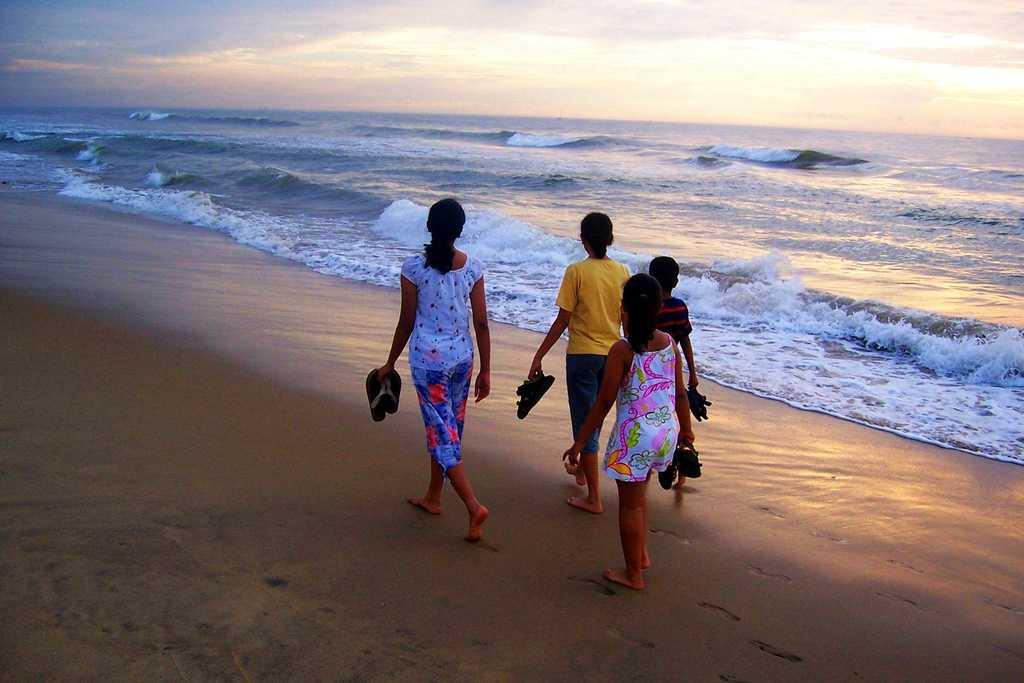How many people are present in the image? There are four people in the image. What are the people doing in the image? The people are walking. What are the people holding while walking? The people are holding footwear. What can be seen in the background of the image? There is sky, clouds, and water visible in the background of the image. What type of plate is being used by the passenger in the image? There is no plate or passenger present in the image. What direction are the people looking in the image? The provided facts do not mention the direction the people are looking, so we cannot answer this question definitively. 